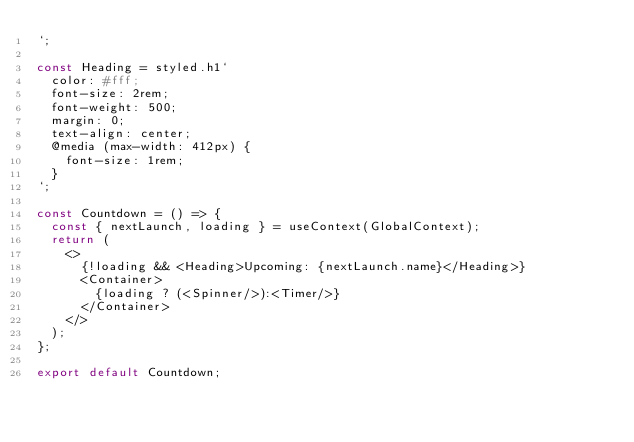Convert code to text. <code><loc_0><loc_0><loc_500><loc_500><_JavaScript_>`;

const Heading = styled.h1`
  color: #fff;
  font-size: 2rem;
  font-weight: 500;
  margin: 0;
  text-align: center;
  @media (max-width: 412px) {
    font-size: 1rem;
  }
`;

const Countdown = () => {
  const { nextLaunch, loading } = useContext(GlobalContext);
  return (
    <>
      {!loading && <Heading>Upcoming: {nextLaunch.name}</Heading>}
      <Container>
        {loading ? (<Spinner/>):<Timer/>}
      </Container>
    </>
  );
};

export default Countdown;
</code> 